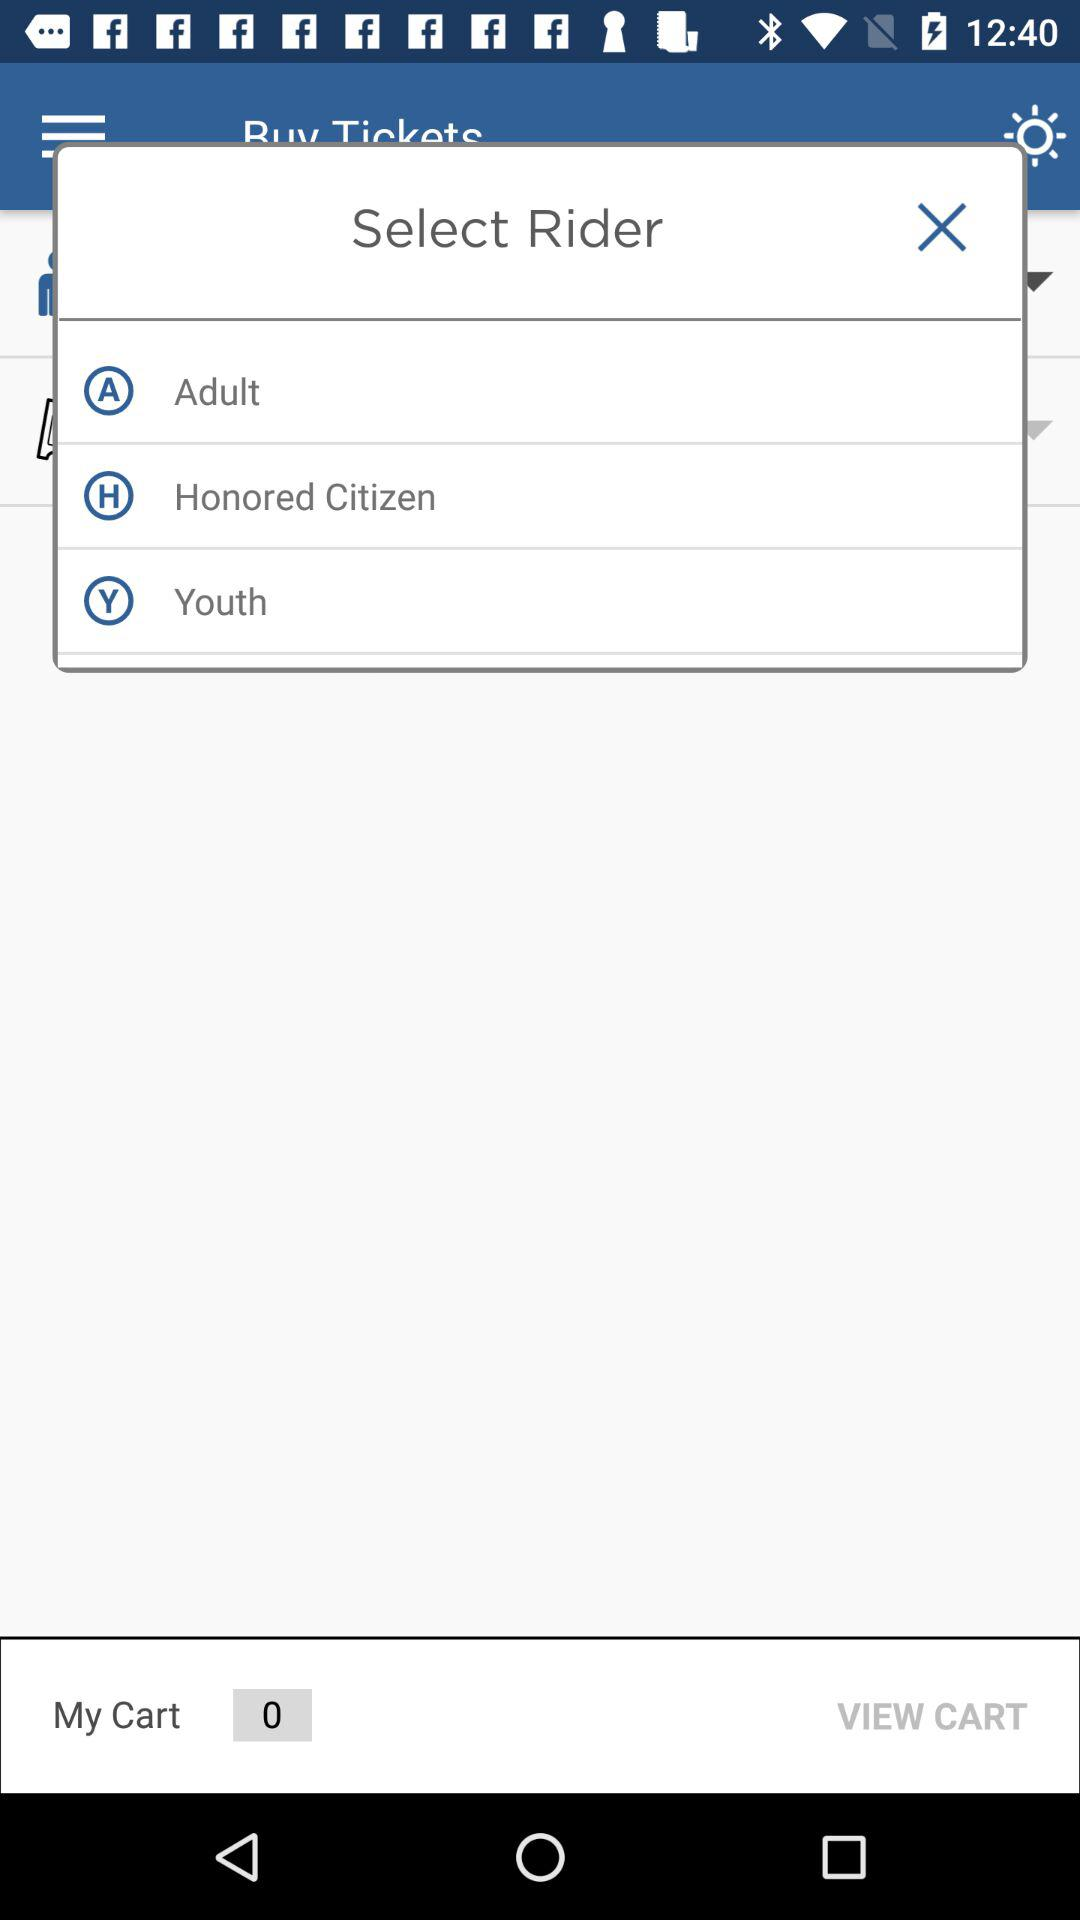How many age options are there for the ticket selection?
Answer the question using a single word or phrase. 3 